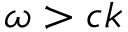<formula> <loc_0><loc_0><loc_500><loc_500>\omega > c k</formula> 